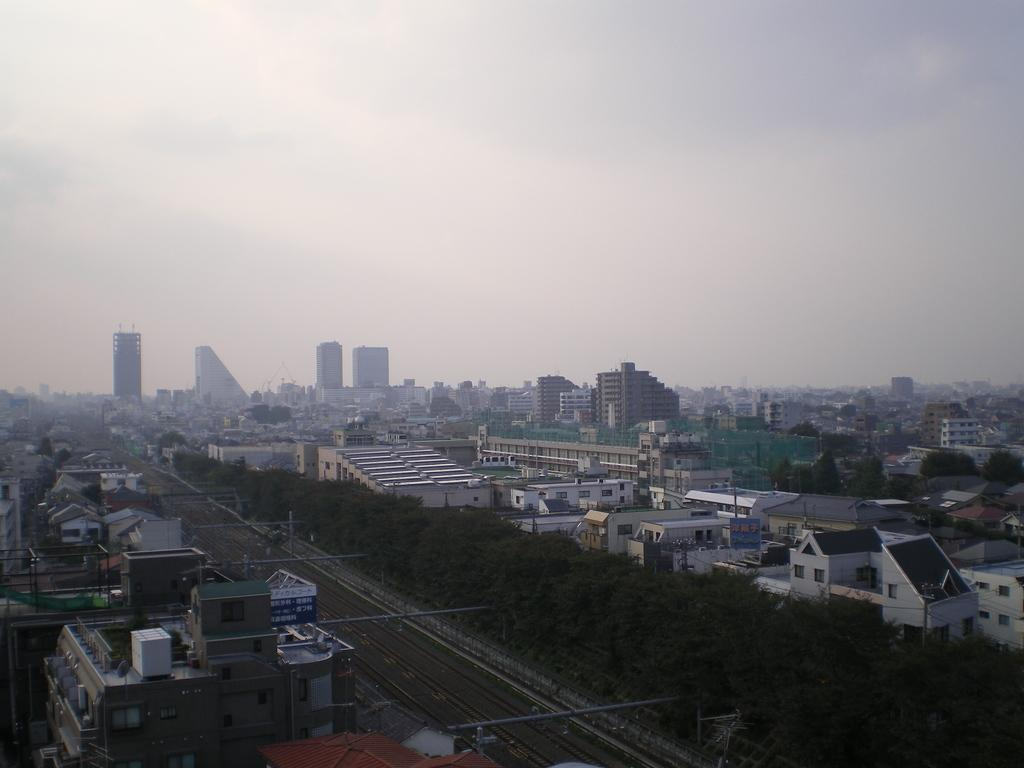What type of structures are present in the image? There are buildings in the image. What other natural elements can be seen in the image? There are trees in the image. What is at the bottom of the image? There is a road at the bottom of the image. What is visible at the top of the image? The sky is visible at the top of the image. Can you tell me how many roses are growing on the trees in the image? There are no roses present on the trees in the image; it features buildings, trees, a road, and the sky. What action is being performed by the buildings in the image? Buildings are inanimate objects and do not perform actions; they are stationary structures in the image. 